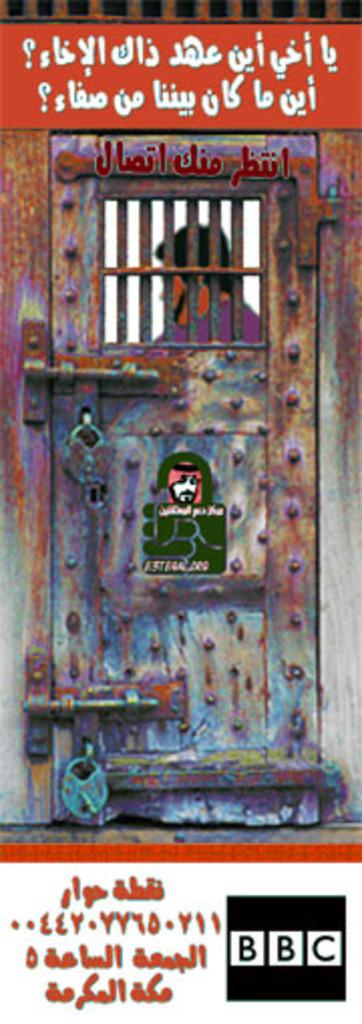What is the main subject of the image? There is a picture of a person in the image. Where is the person located in relation to the door? The person is standing beside the door. What is the status of the door in the image? The door is locked. What additional information can be seen on the door? There is text visible on the door and a logo. What hobbies does the person in the image enjoy during a rainstorm? There is no information about the person's hobbies or a rainstorm in the image. 